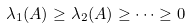<formula> <loc_0><loc_0><loc_500><loc_500>\lambda _ { 1 } ( A ) \geq \lambda _ { 2 } ( A ) \geq \dots \geq 0</formula> 